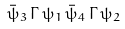Convert formula to latex. <formula><loc_0><loc_0><loc_500><loc_500>\bar { \psi } _ { 3 } \, { \Gamma } \, \psi _ { 1 } \, \bar { \psi } _ { 4 } \, { \Gamma } \, \psi _ { 2 }</formula> 